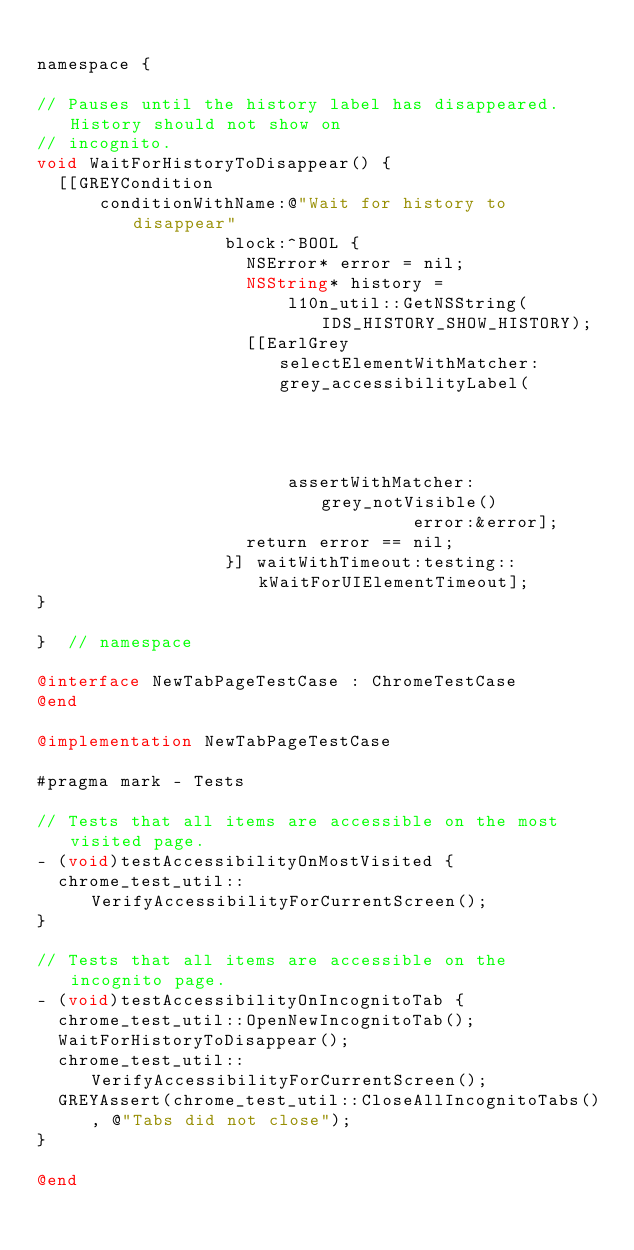Convert code to text. <code><loc_0><loc_0><loc_500><loc_500><_ObjectiveC_>
namespace {

// Pauses until the history label has disappeared.  History should not show on
// incognito.
void WaitForHistoryToDisappear() {
  [[GREYCondition
      conditionWithName:@"Wait for history to disappear"
                  block:^BOOL {
                    NSError* error = nil;
                    NSString* history =
                        l10n_util::GetNSString(IDS_HISTORY_SHOW_HISTORY);
                    [[EarlGrey selectElementWithMatcher:grey_accessibilityLabel(
                                                            history)]
                        assertWithMatcher:grey_notVisible()
                                    error:&error];
                    return error == nil;
                  }] waitWithTimeout:testing::kWaitForUIElementTimeout];
}

}  // namespace

@interface NewTabPageTestCase : ChromeTestCase
@end

@implementation NewTabPageTestCase

#pragma mark - Tests

// Tests that all items are accessible on the most visited page.
- (void)testAccessibilityOnMostVisited {
  chrome_test_util::VerifyAccessibilityForCurrentScreen();
}

// Tests that all items are accessible on the incognito page.
- (void)testAccessibilityOnIncognitoTab {
  chrome_test_util::OpenNewIncognitoTab();
  WaitForHistoryToDisappear();
  chrome_test_util::VerifyAccessibilityForCurrentScreen();
  GREYAssert(chrome_test_util::CloseAllIncognitoTabs(), @"Tabs did not close");
}

@end
</code> 